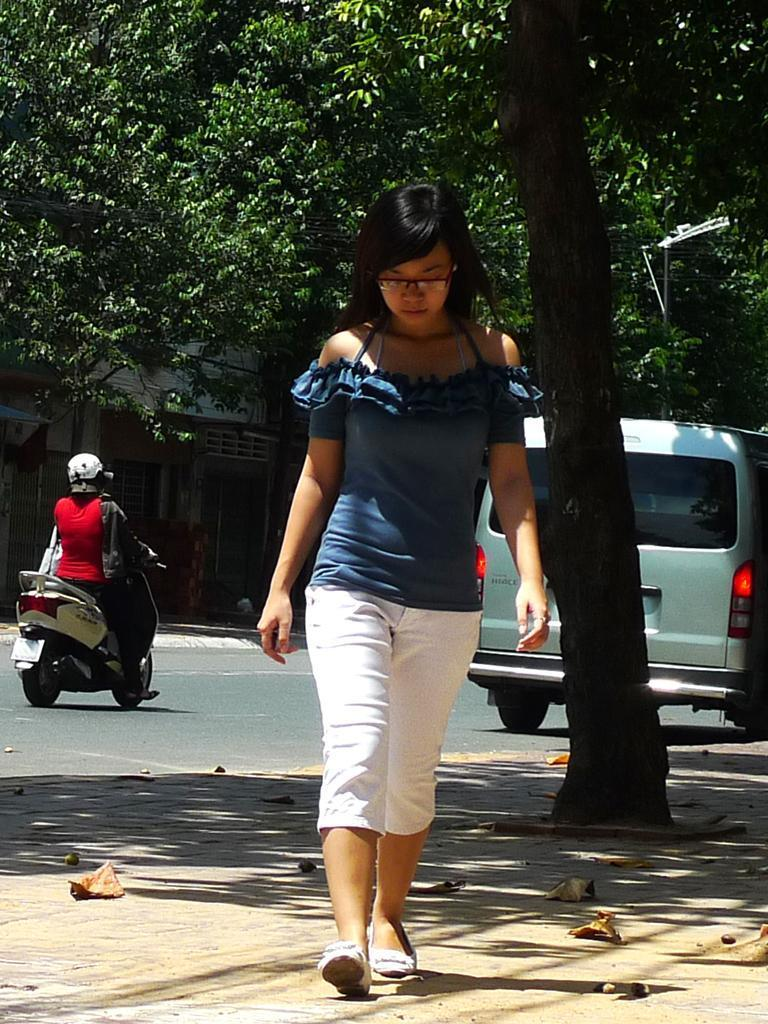What is happening in the foreground of the image? There is a woman walking in the foreground of the image. What surface is the woman walking on? The woman is walking on the pavement. What can be seen in the background of the image? There is a tree, two vehicles moving on the road, and a building in the background of the image. What grade of pail is being used by the woman in the image? There is no pail present in the image, so it is not possible to determine the grade of any pail. 